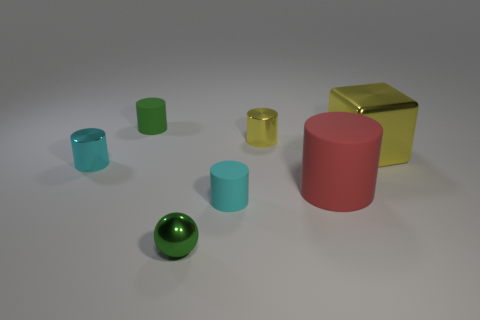There is a small shiny thing on the right side of the tiny cyan cylinder right of the metal cylinder in front of the tiny yellow metallic cylinder; what is its shape?
Provide a succinct answer. Cylinder. There is a tiny object that is right of the green sphere and behind the large red rubber object; what shape is it?
Offer a very short reply. Cylinder. There is a object that is on the right side of the tiny yellow metallic cylinder and to the left of the metal cube; what is it made of?
Offer a terse response. Rubber. How many large red things have the same shape as the small cyan metal object?
Your answer should be very brief. 1. What material is the yellow object to the right of the small yellow metallic object?
Provide a short and direct response. Metal. Is the number of small cyan cylinders right of the large rubber cylinder less than the number of tiny brown metallic balls?
Offer a terse response. No. Does the green matte object have the same shape as the green shiny object?
Provide a short and direct response. No. Is there any other thing that is the same shape as the small green shiny object?
Keep it short and to the point. No. Are any cyan metallic cylinders visible?
Provide a short and direct response. Yes. There is a cyan rubber thing; is its shape the same as the tiny matte thing behind the big cylinder?
Your answer should be compact. Yes. 